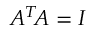<formula> <loc_0><loc_0><loc_500><loc_500>A ^ { T } \, A = I</formula> 